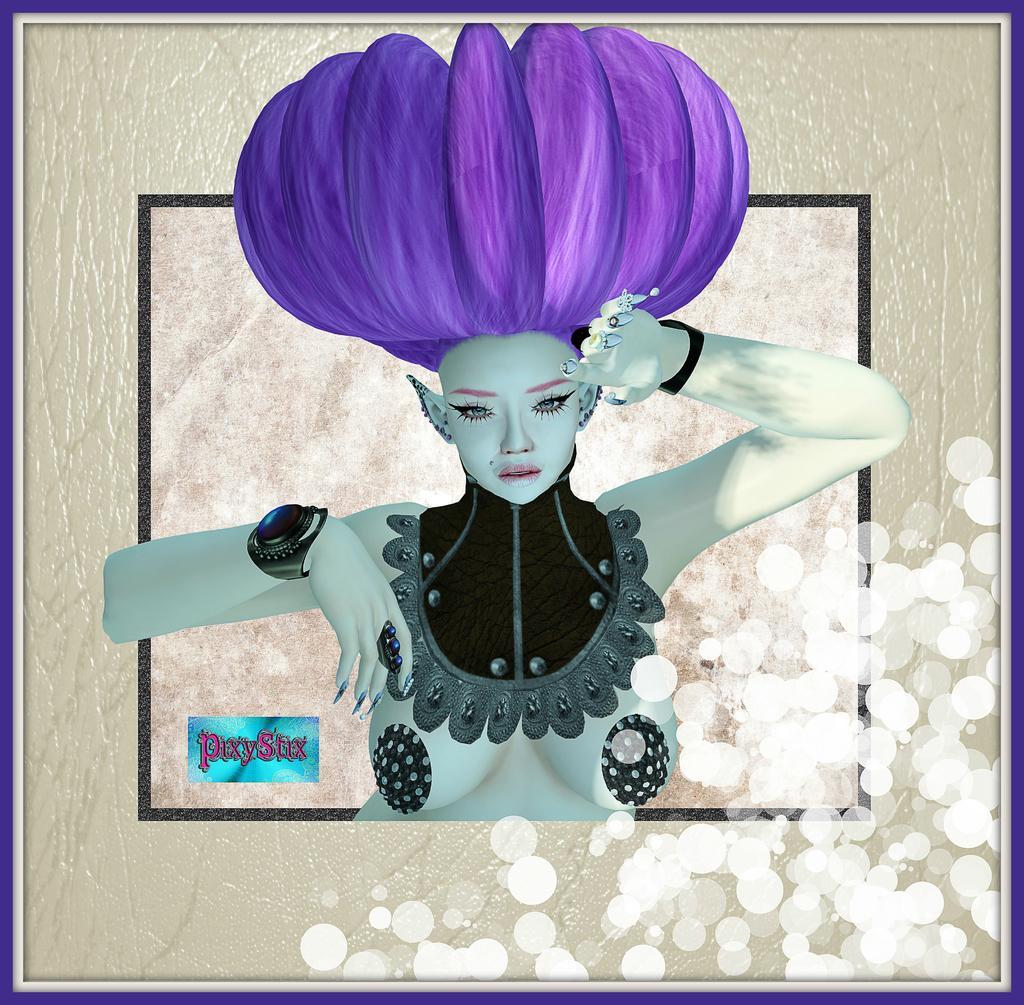Can you describe this image briefly? In this picture we can see a frame, where we can find a woman, and also we can see some text. 